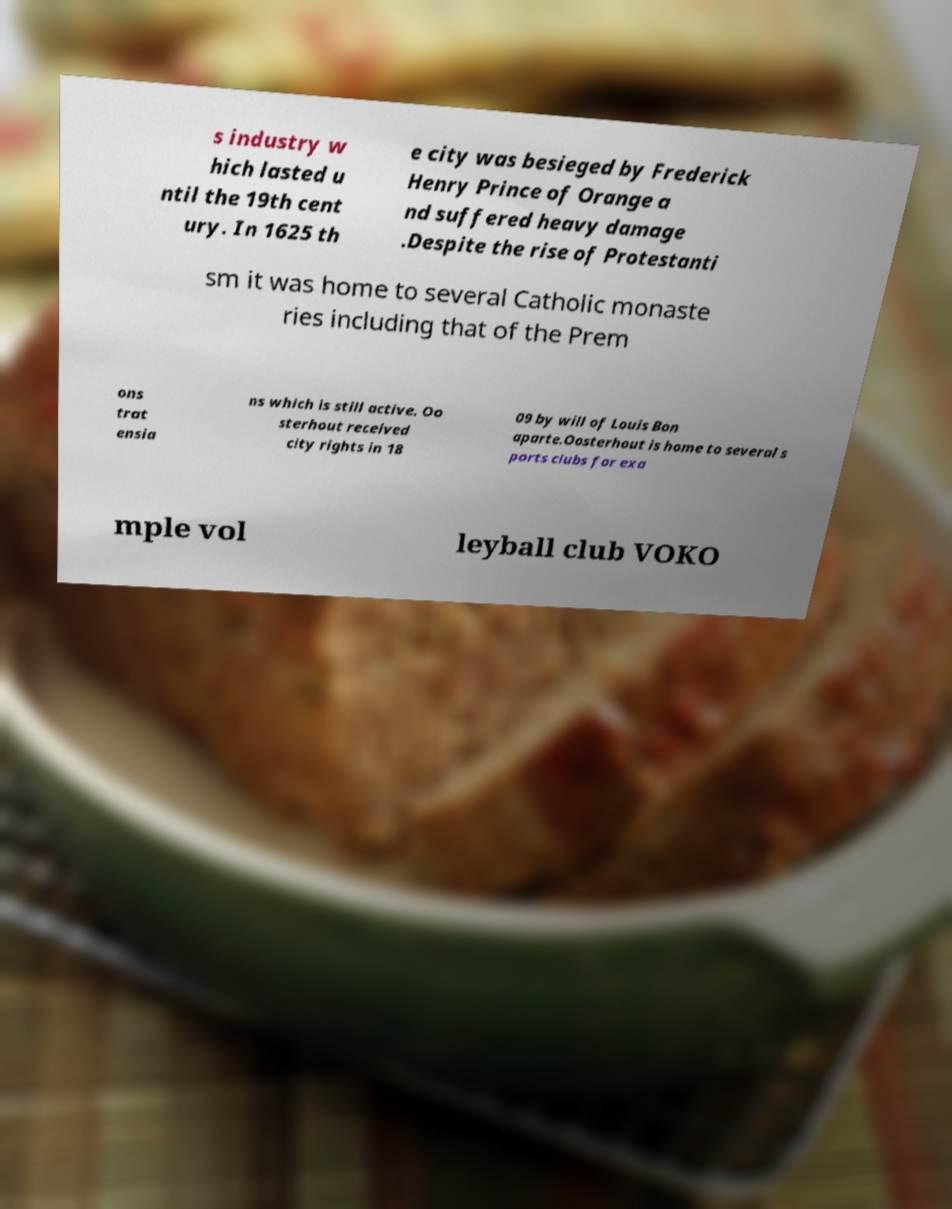Please identify and transcribe the text found in this image. s industry w hich lasted u ntil the 19th cent ury. In 1625 th e city was besieged by Frederick Henry Prince of Orange a nd suffered heavy damage .Despite the rise of Protestanti sm it was home to several Catholic monaste ries including that of the Prem ons trat ensia ns which is still active. Oo sterhout received city rights in 18 09 by will of Louis Bon aparte.Oosterhout is home to several s ports clubs for exa mple vol leyball club VOKO 